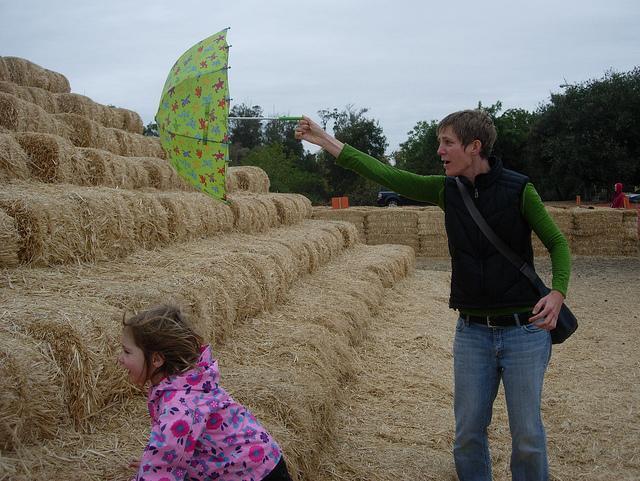How many people are there?
Give a very brief answer. 2. 